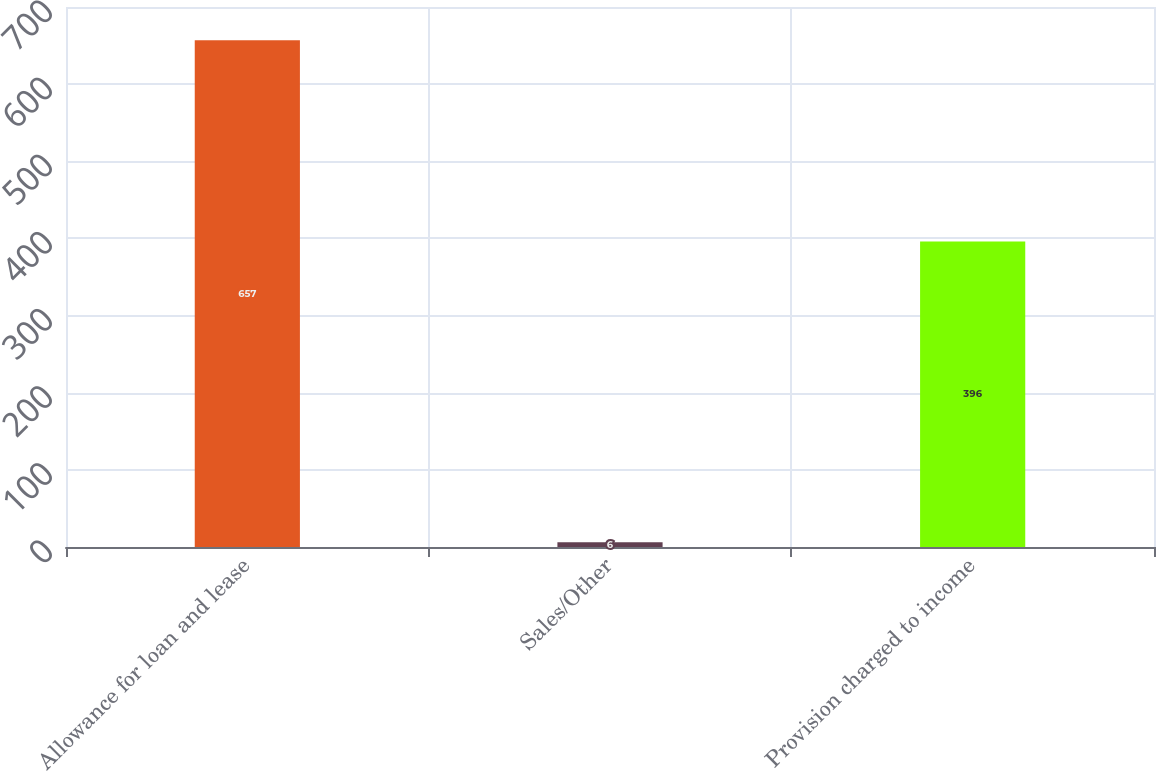Convert chart. <chart><loc_0><loc_0><loc_500><loc_500><bar_chart><fcel>Allowance for loan and lease<fcel>Sales/Other<fcel>Provision charged to income<nl><fcel>657<fcel>6<fcel>396<nl></chart> 